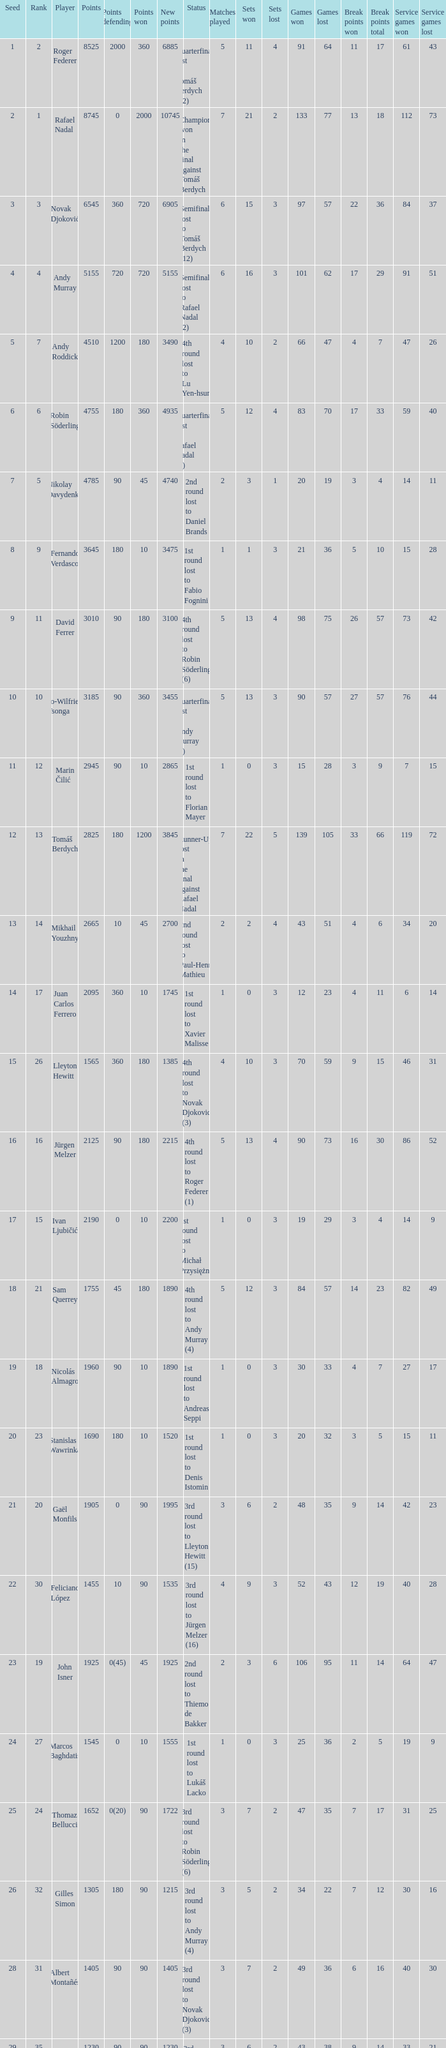Name the least new points for points defending is 1200 3490.0. 